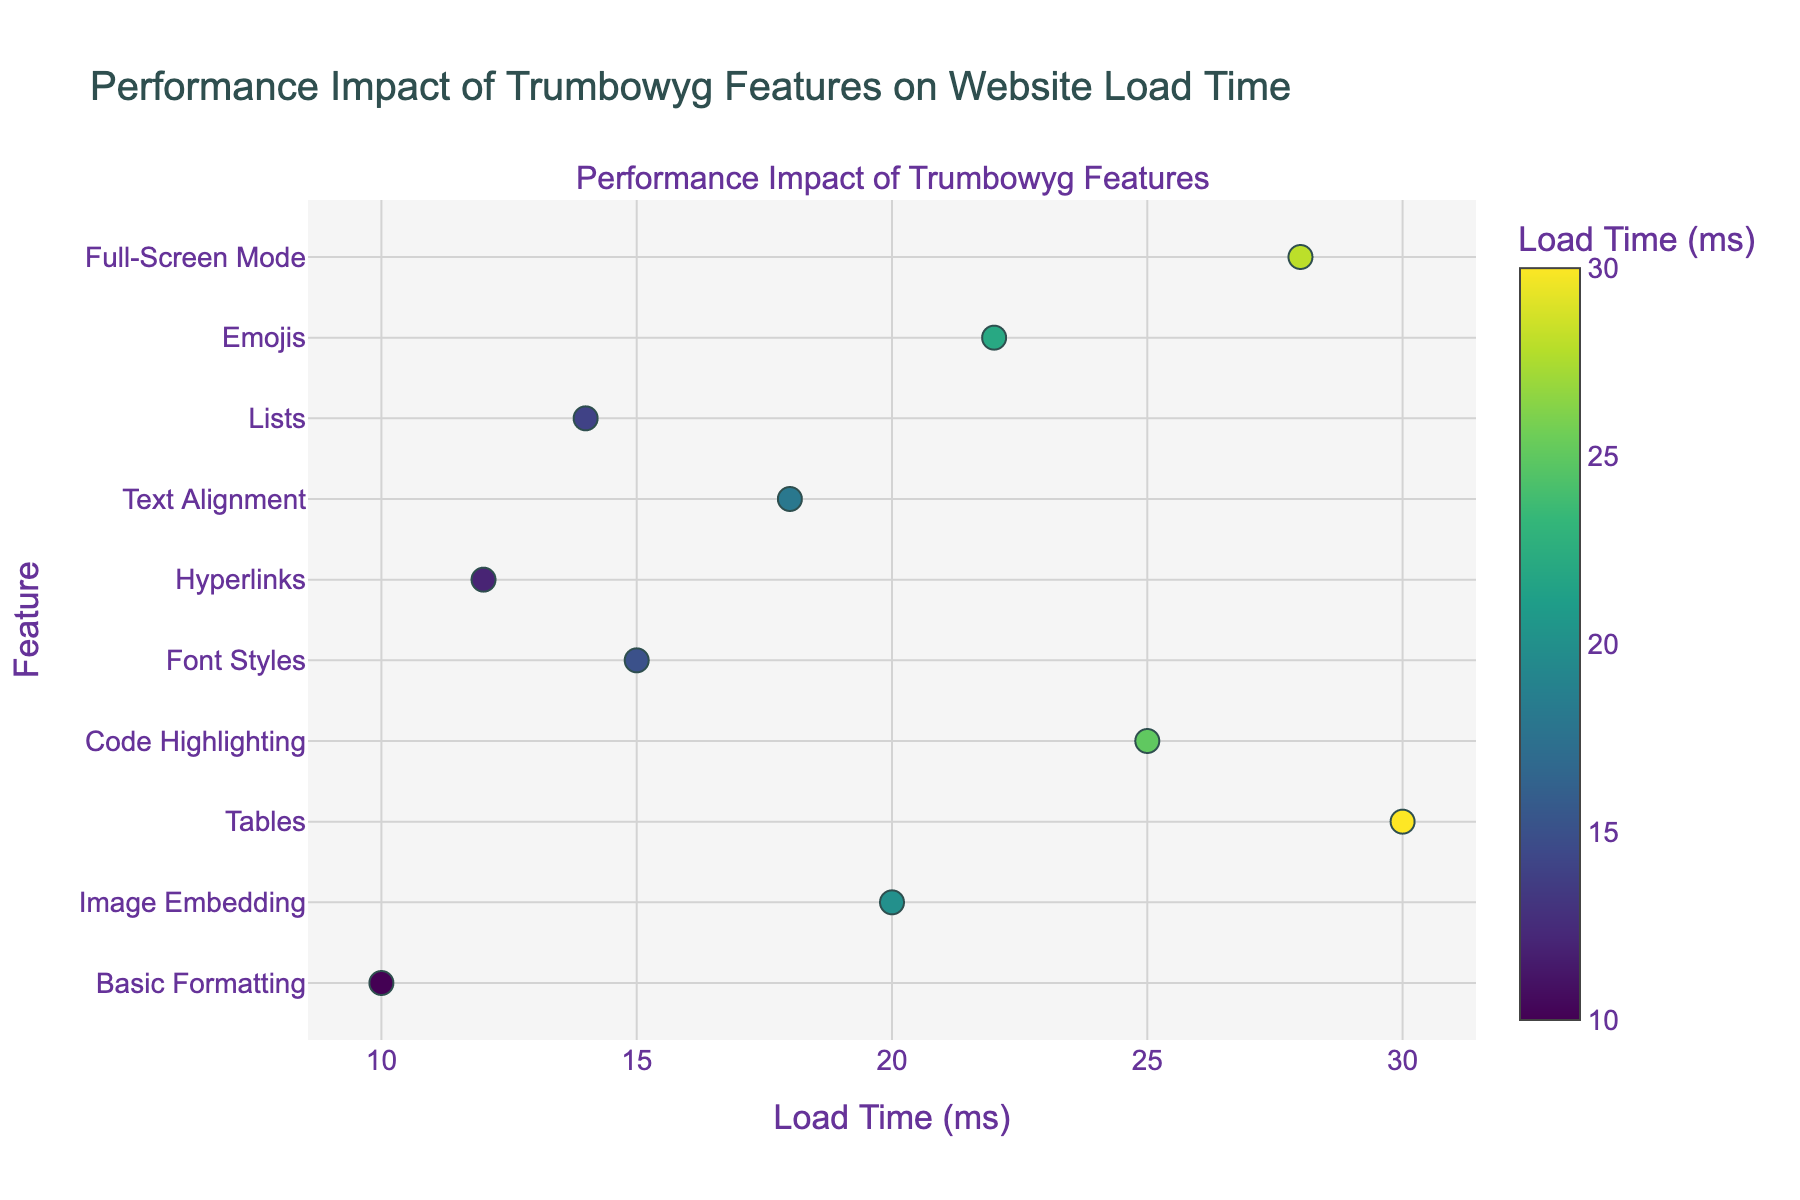What's the title of the plot? The title is located at the top center of the figure and reads "Performance Impact of Trumbowyg Features on Website Load Time".
Answer: Performance Impact of Trumbowyg Features on Website Load Time What is the feature associated with the highest load time? By looking at the scatter plot, the feature with the highest load time will be the marker farthest on the right side of the x-axis at 30 ms. The corresponding y-axis label is "Tables".
Answer: Tables How many features have a load time greater than 20 ms? By checking the scatter points with an x-value more than 20 ms, we find the points corresponding to Image Embedding (20 ms), Code Highlighting (25 ms), Emojis (22 ms), and Full-Screen Mode (28 ms).
Answer: 4 Which feature has the smallest load time and what is it? Find the point closest to the left end of the x-axis. The corresponding y-axis label and x-axis value give the feature and load time respectively. The smallest load time is 10 ms for "Basic Formatting".
Answer: Basic Formatting, 10 ms How does the load time for Lists compare to Text Alignment? To compare, look at the x-axis values for "Lists" and "Text Alignment". Lists has a load time of 14 ms whereas Text Alignment has a load time of 18 ms. Lists has a smaller load time compared to Text Alignment.
Answer: 14 ms is less than 18 ms Which three features have the middle load times, and what are they? Sort the list of load times and select the three from the middle. Sorting: 10, 12, 14, 15, 18, 20, 22, 25, 28, 30. The middle three are the 5th, 6th, and 7th values, which are Text Alignment (18 ms), Image Embedding (20 ms), and Emojis (22 ms).
Answer: Text Alignment, Image Embedding, Emojis What is the color associated with "Emojis" in the plot? Look at the color scale and observe the marker for "Emojis" at 22 ms. The color representing 22 ms falls within the values shown on the 'Viridis' colorscale.
Answer: Greenish Yellow 